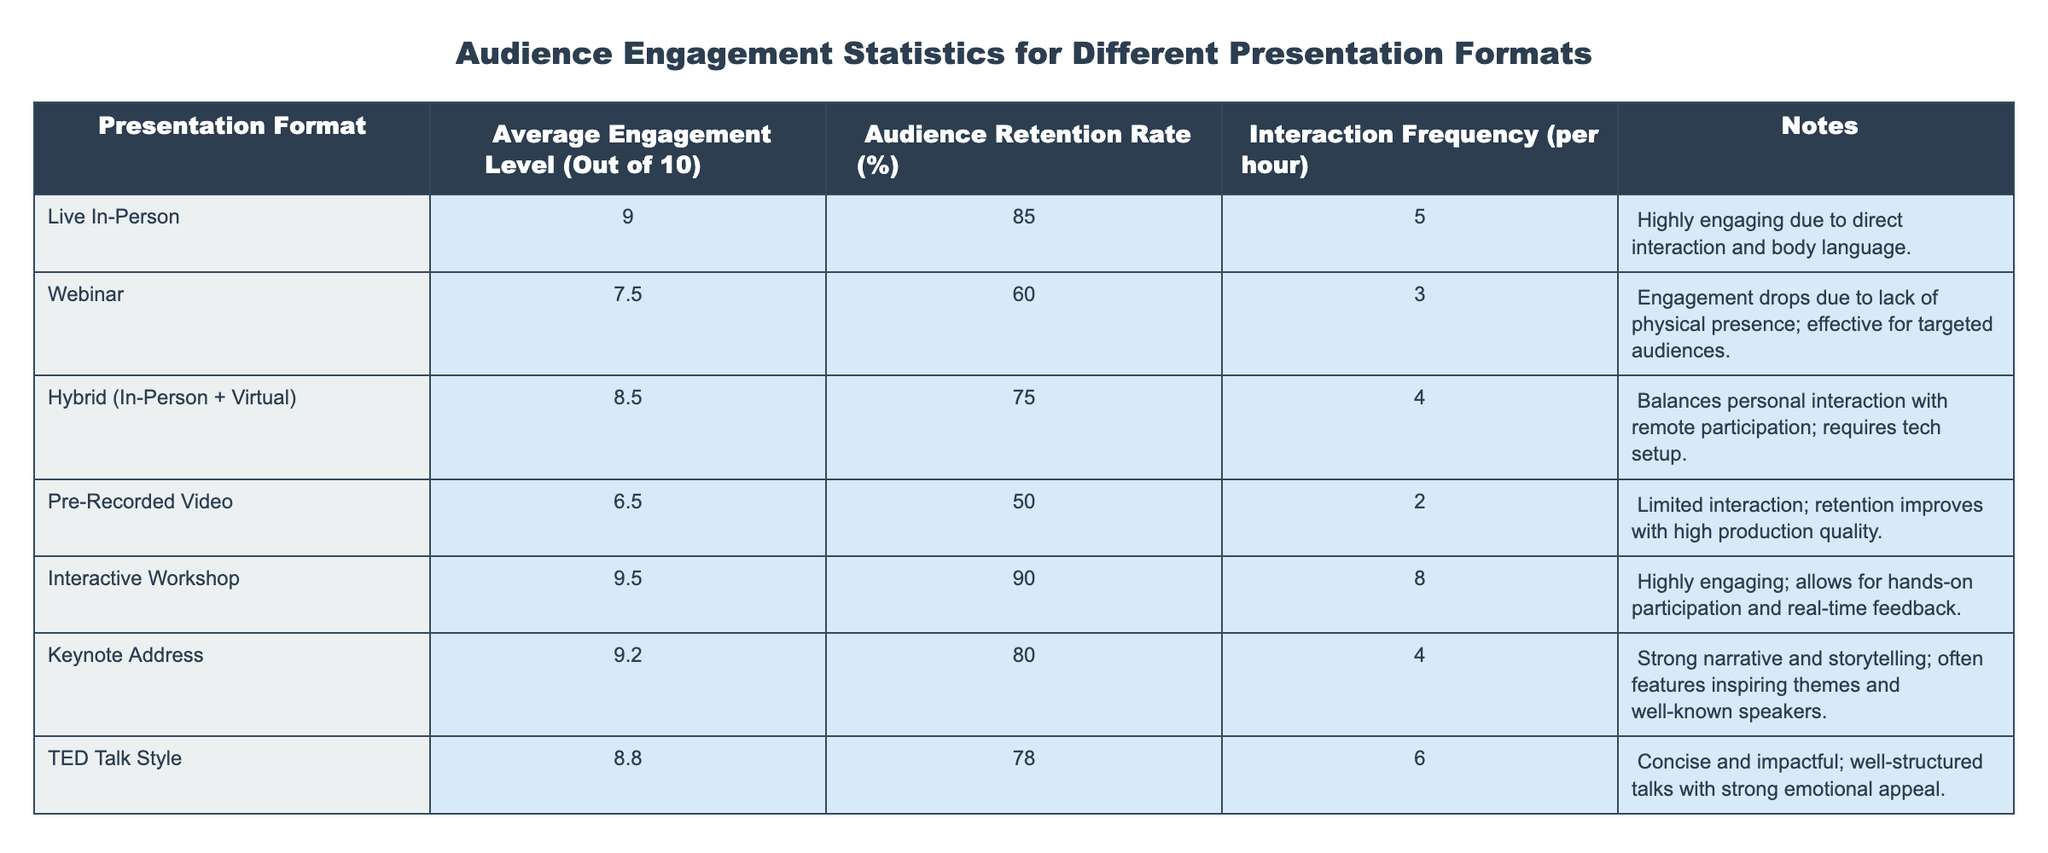What is the average engagement level for Interactive Workshops? The table shows that the average engagement level for Interactive Workshops is explicitly stated as 9.5.
Answer: 9.5 Which presentation format has the highest audience retention rate? By comparing the audience retention rates listed in the table, Interactive Workshop has the highest rate at 90%.
Answer: 90% What is the interaction frequency of Pre-Recorded Videos? The table lists the interaction frequency for Pre-Recorded Videos as 2 interactions per hour.
Answer: 2 How does the audience retention rate of Webinars compare to Live In-Person presentations? The audience retention rate for Webinars is 60%, while for Live In-Person presentations it is 85%. This shows that Live In-Person presentations have a significantly higher retention rate.
Answer: 85% vs. 60% What is the average engagement level for all presentation formats combined? To find the average, sum the engagement levels (9.0 + 7.5 + 8.5 + 6.5 + 9.5 + 9.2 + 8.8) = 59.0. There are 7 formats, so the average is 59.0 / 7 = 8.43.
Answer: 8.43 Are Pre-Recorded Videos more engaging than Webinars? The average engagement level for Pre-Recorded Videos is 6.5, while for Webinars it is 7.5. Since 6.5 is less than 7.5, Pre-Recorded Videos are not more engaging than Webinars.
Answer: No Which formats have an interaction frequency of 4 per hour? The table indicates that both Hybrid and Keynote Address formats have an interaction frequency of 4 per hour.
Answer: Hybrid and Keynote Address What is the difference in audience retention rate between Keynote Addresses and TED Talk Styles? Keynote Addresses have an audience retention rate of 80%, while TED Talk Styles have a rate of 78%. The difference is 80% - 78% = 2%.
Answer: 2% Which presentation format has the lowest average engagement level? Comparing the average engagement levels, Pre-Recorded Videos have the lowest level at 6.5.
Answer: 6.5 Is the interaction frequency for Interactive Workshops higher than that for Hybrid presentations? The table shows that Interactive Workshops have an interaction frequency of 8, while Hybrid presentations have 4. Since 8 is greater than 4, the interaction frequency for Interactive Workshops is indeed higher.
Answer: Yes 